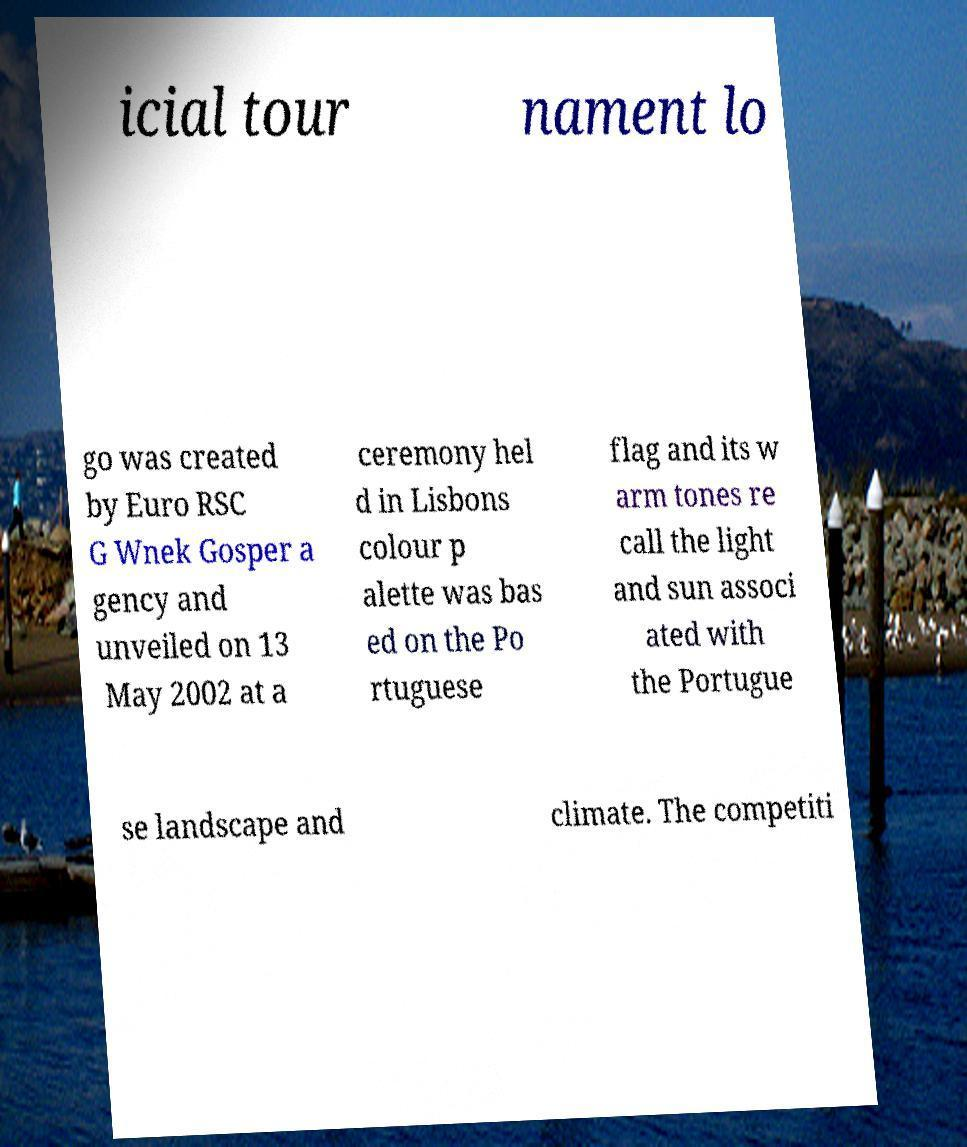For documentation purposes, I need the text within this image transcribed. Could you provide that? icial tour nament lo go was created by Euro RSC G Wnek Gosper a gency and unveiled on 13 May 2002 at a ceremony hel d in Lisbons colour p alette was bas ed on the Po rtuguese flag and its w arm tones re call the light and sun associ ated with the Portugue se landscape and climate. The competiti 